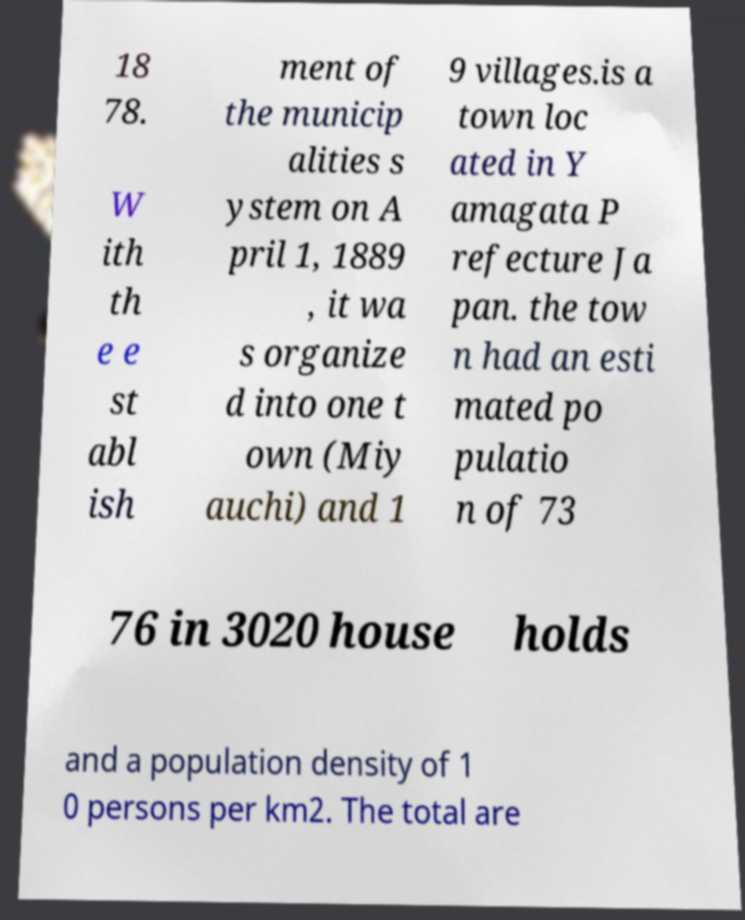I need the written content from this picture converted into text. Can you do that? 18 78. W ith th e e st abl ish ment of the municip alities s ystem on A pril 1, 1889 , it wa s organize d into one t own (Miy auchi) and 1 9 villages.is a town loc ated in Y amagata P refecture Ja pan. the tow n had an esti mated po pulatio n of 73 76 in 3020 house holds and a population density of 1 0 persons per km2. The total are 